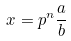<formula> <loc_0><loc_0><loc_500><loc_500>x = p ^ { n } \frac { a } { b }</formula> 